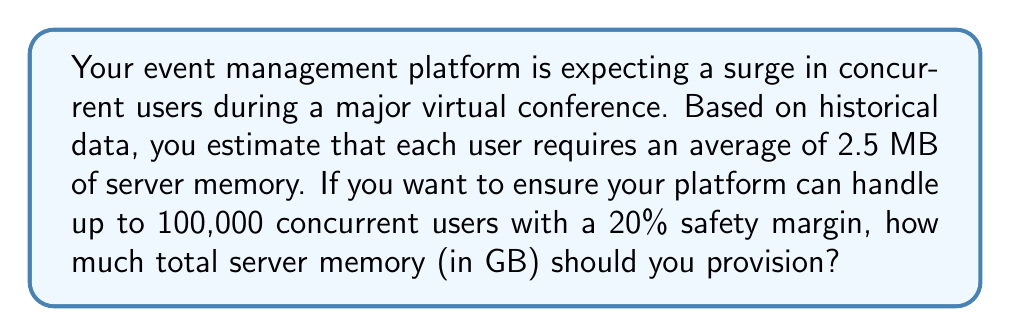Can you answer this question? To solve this problem, we'll follow these steps:

1. Calculate the base memory requirement for 100,000 users:
   $$100,000 \text{ users} \times 2.5 \text{ MB/user} = 250,000 \text{ MB}$$

2. Convert MB to GB:
   $$250,000 \text{ MB} \times \frac{1 \text{ GB}}{1024 \text{ MB}} \approx 244.14 \text{ GB}$$

3. Add the 20% safety margin:
   Let $x$ be the total memory needed with the safety margin.
   $$x = 244.14 \text{ GB} + (0.20 \times 244.14 \text{ GB})$$
   $$x = 244.14 \text{ GB} + 48.828 \text{ GB}$$
   $$x = 292.968 \text{ GB}$$

4. Round up to the nearest whole number for practical provisioning:
   $$\text{Total memory to provision} = \lceil 292.968 \text{ GB} \rceil = 293 \text{ GB}$$

Therefore, to handle 100,000 concurrent users with a 20% safety margin, you should provision 293 GB of server memory.
Answer: 293 GB 